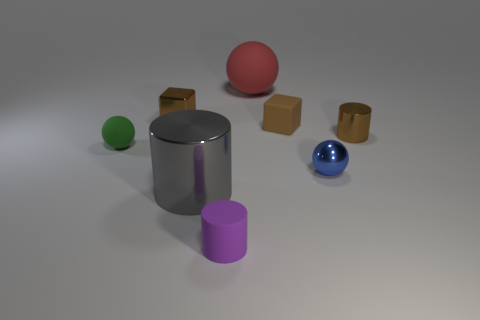The large gray shiny object is what shape?
Your answer should be very brief. Cylinder. There is a cylinder that is left of the small cylinder that is in front of the blue shiny object; what number of green matte balls are behind it?
Provide a succinct answer. 1. What is the color of the small metal object that is the same shape as the brown matte thing?
Provide a short and direct response. Brown. What is the shape of the small metal object in front of the cylinder that is to the right of the matte ball to the right of the small purple thing?
Provide a short and direct response. Sphere. There is a ball that is both right of the tiny rubber ball and in front of the tiny brown shiny block; what size is it?
Make the answer very short. Small. Is the number of tiny purple objects less than the number of small rubber things?
Offer a terse response. Yes. There is a thing on the right side of the blue metallic sphere; how big is it?
Keep it short and to the point. Small. The small rubber object that is both behind the blue metallic sphere and to the right of the tiny green sphere has what shape?
Provide a succinct answer. Cube. There is a red rubber object that is the same shape as the small blue object; what is its size?
Make the answer very short. Large. What number of large red balls have the same material as the big cylinder?
Your response must be concise. 0. 